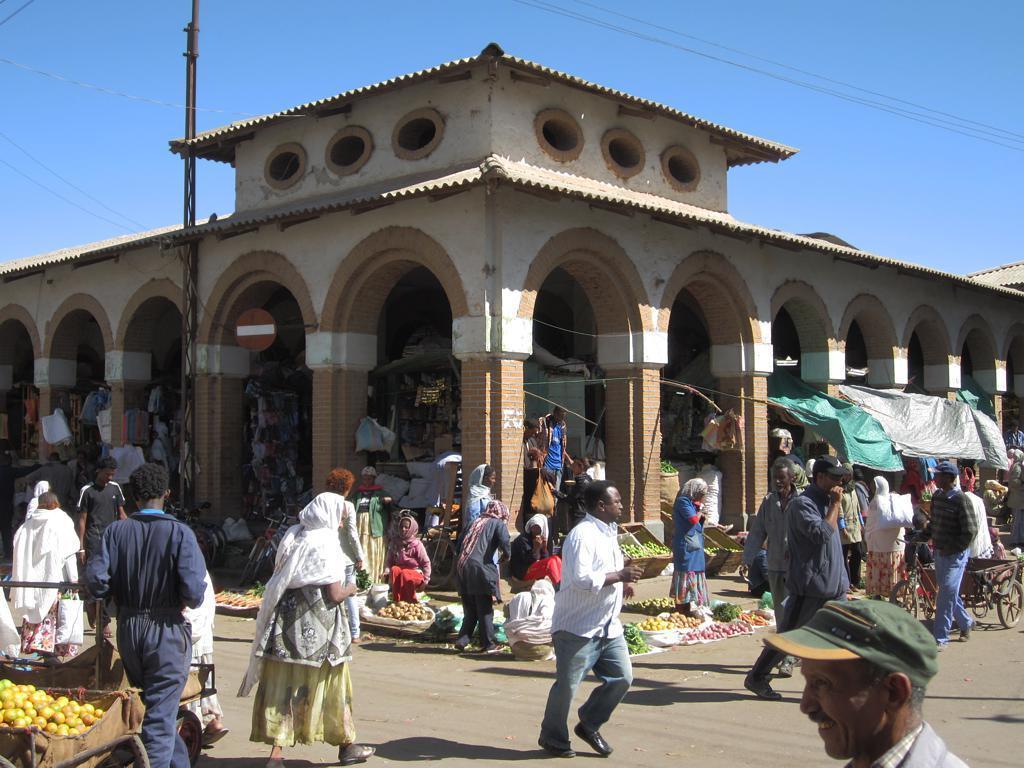In one or two sentences, can you explain what this image depicts? In this image I can see few persons walking on the road. I can see few vegetables and food items. In the background there is a building. At the top I can see the sky. 